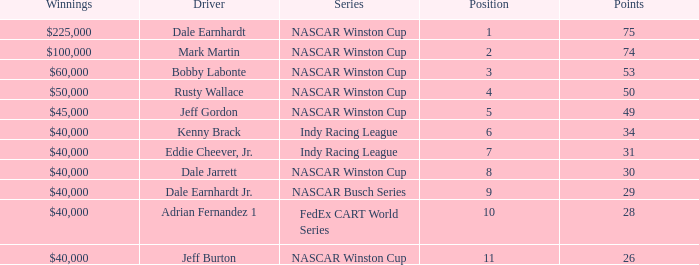In what position was the driver who won $60,000? 3.0. 